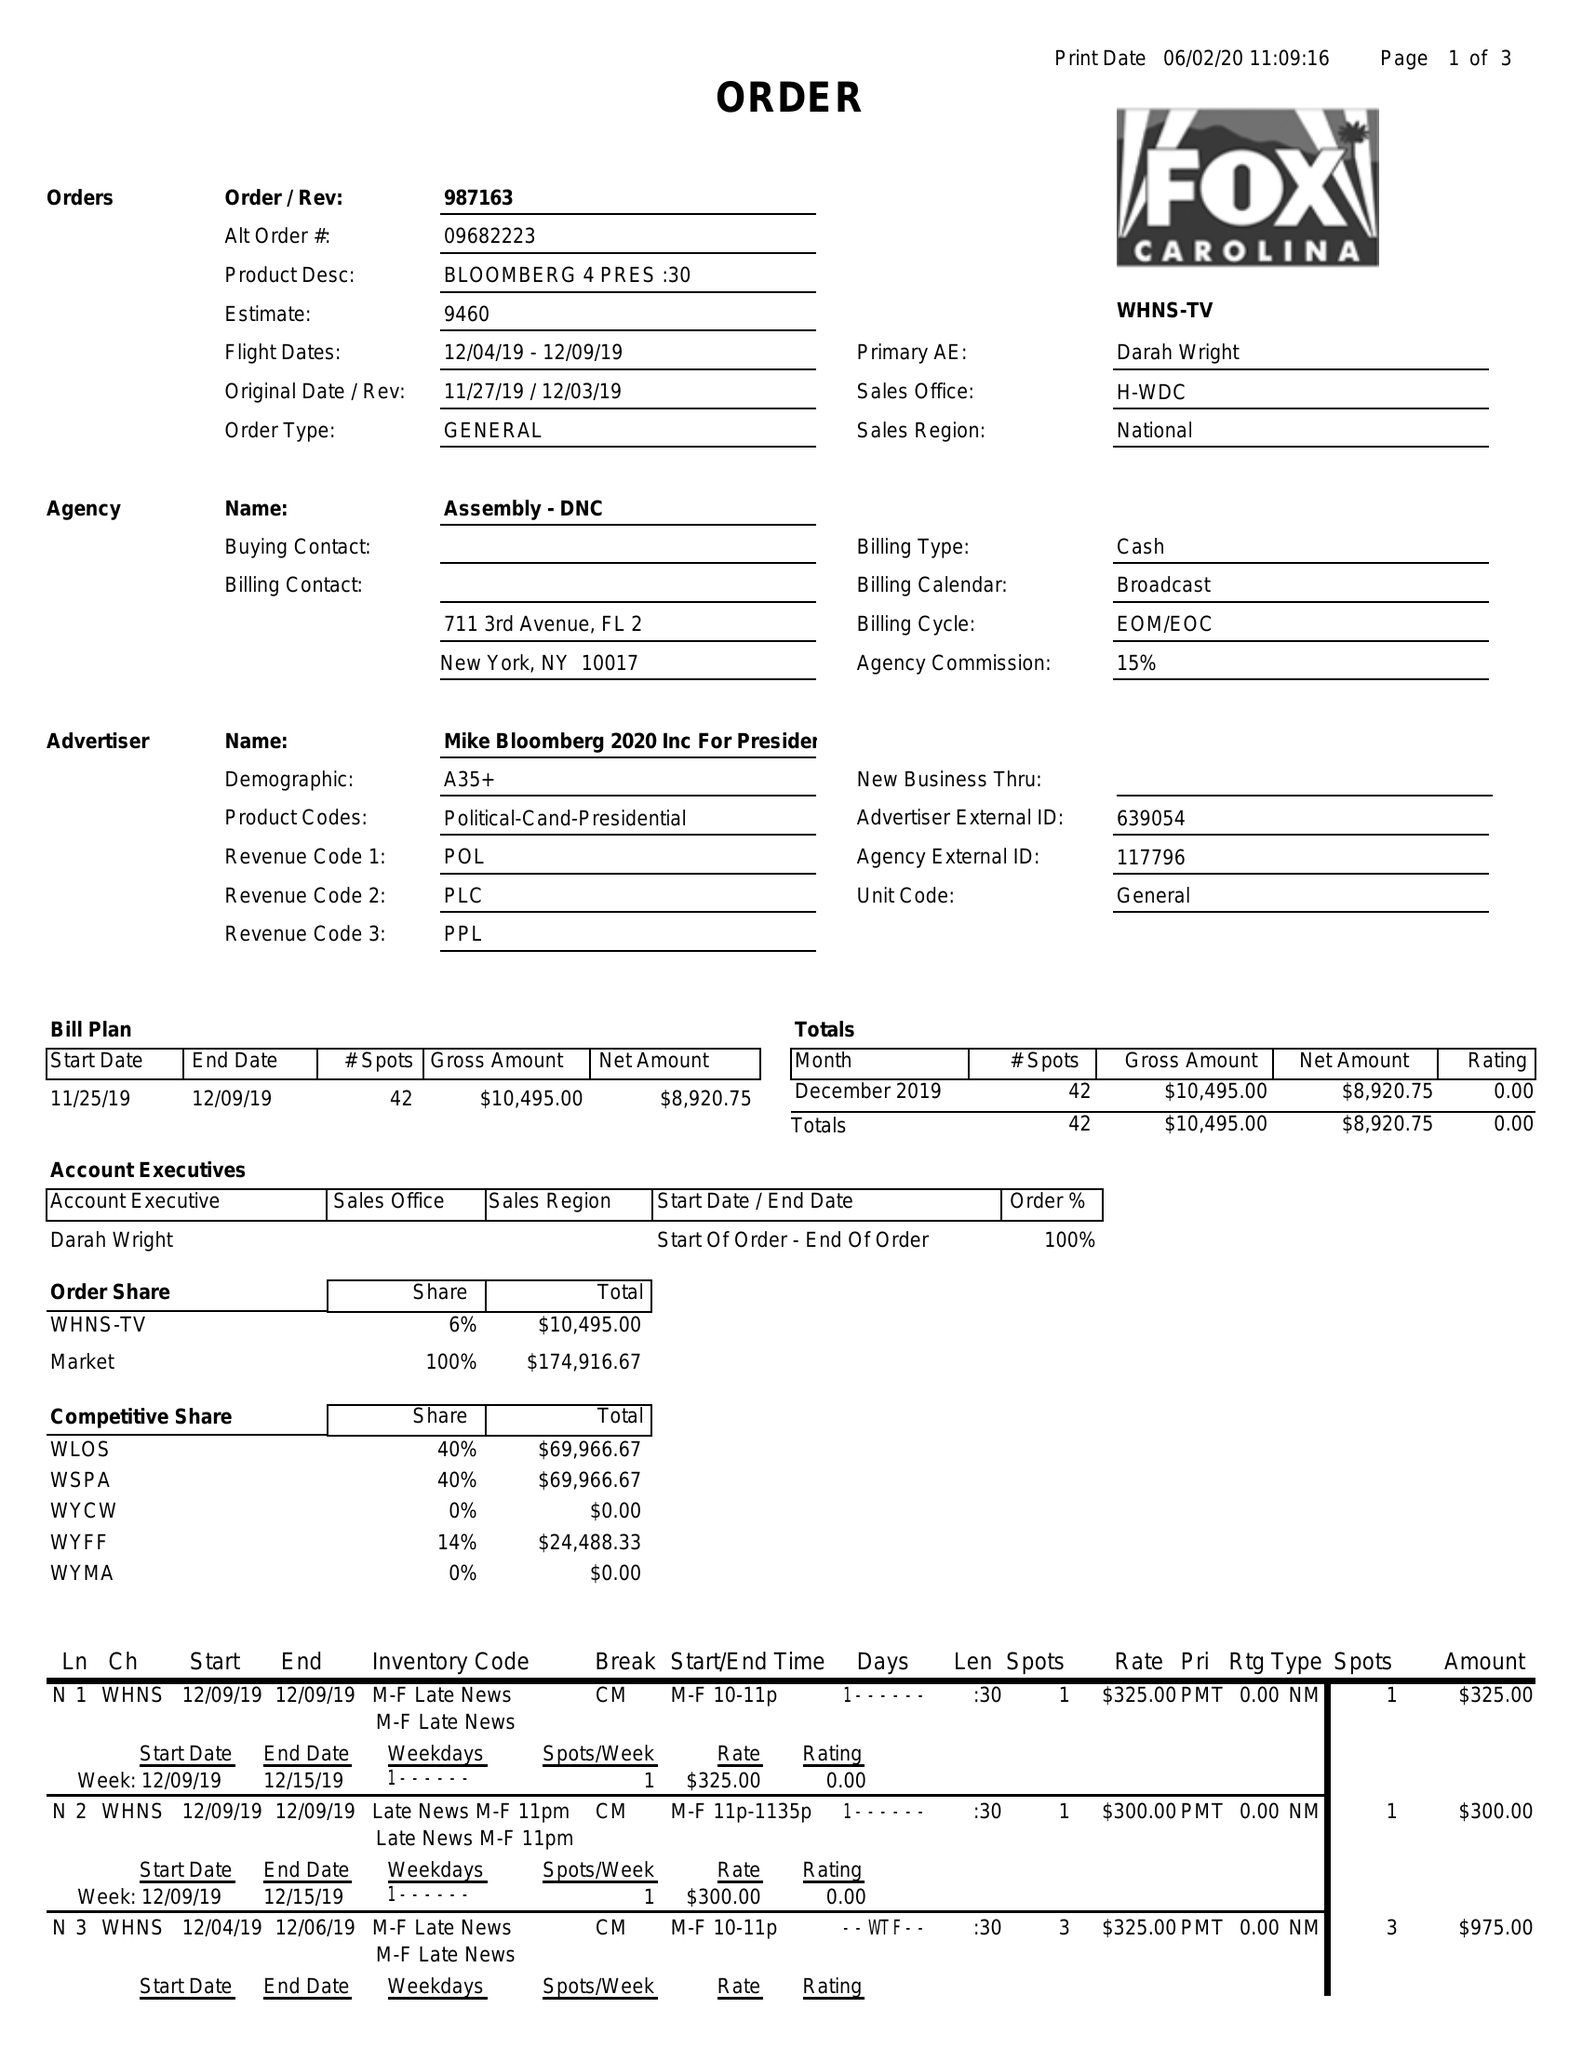What is the value for the flight_from?
Answer the question using a single word or phrase. 12/04/19 